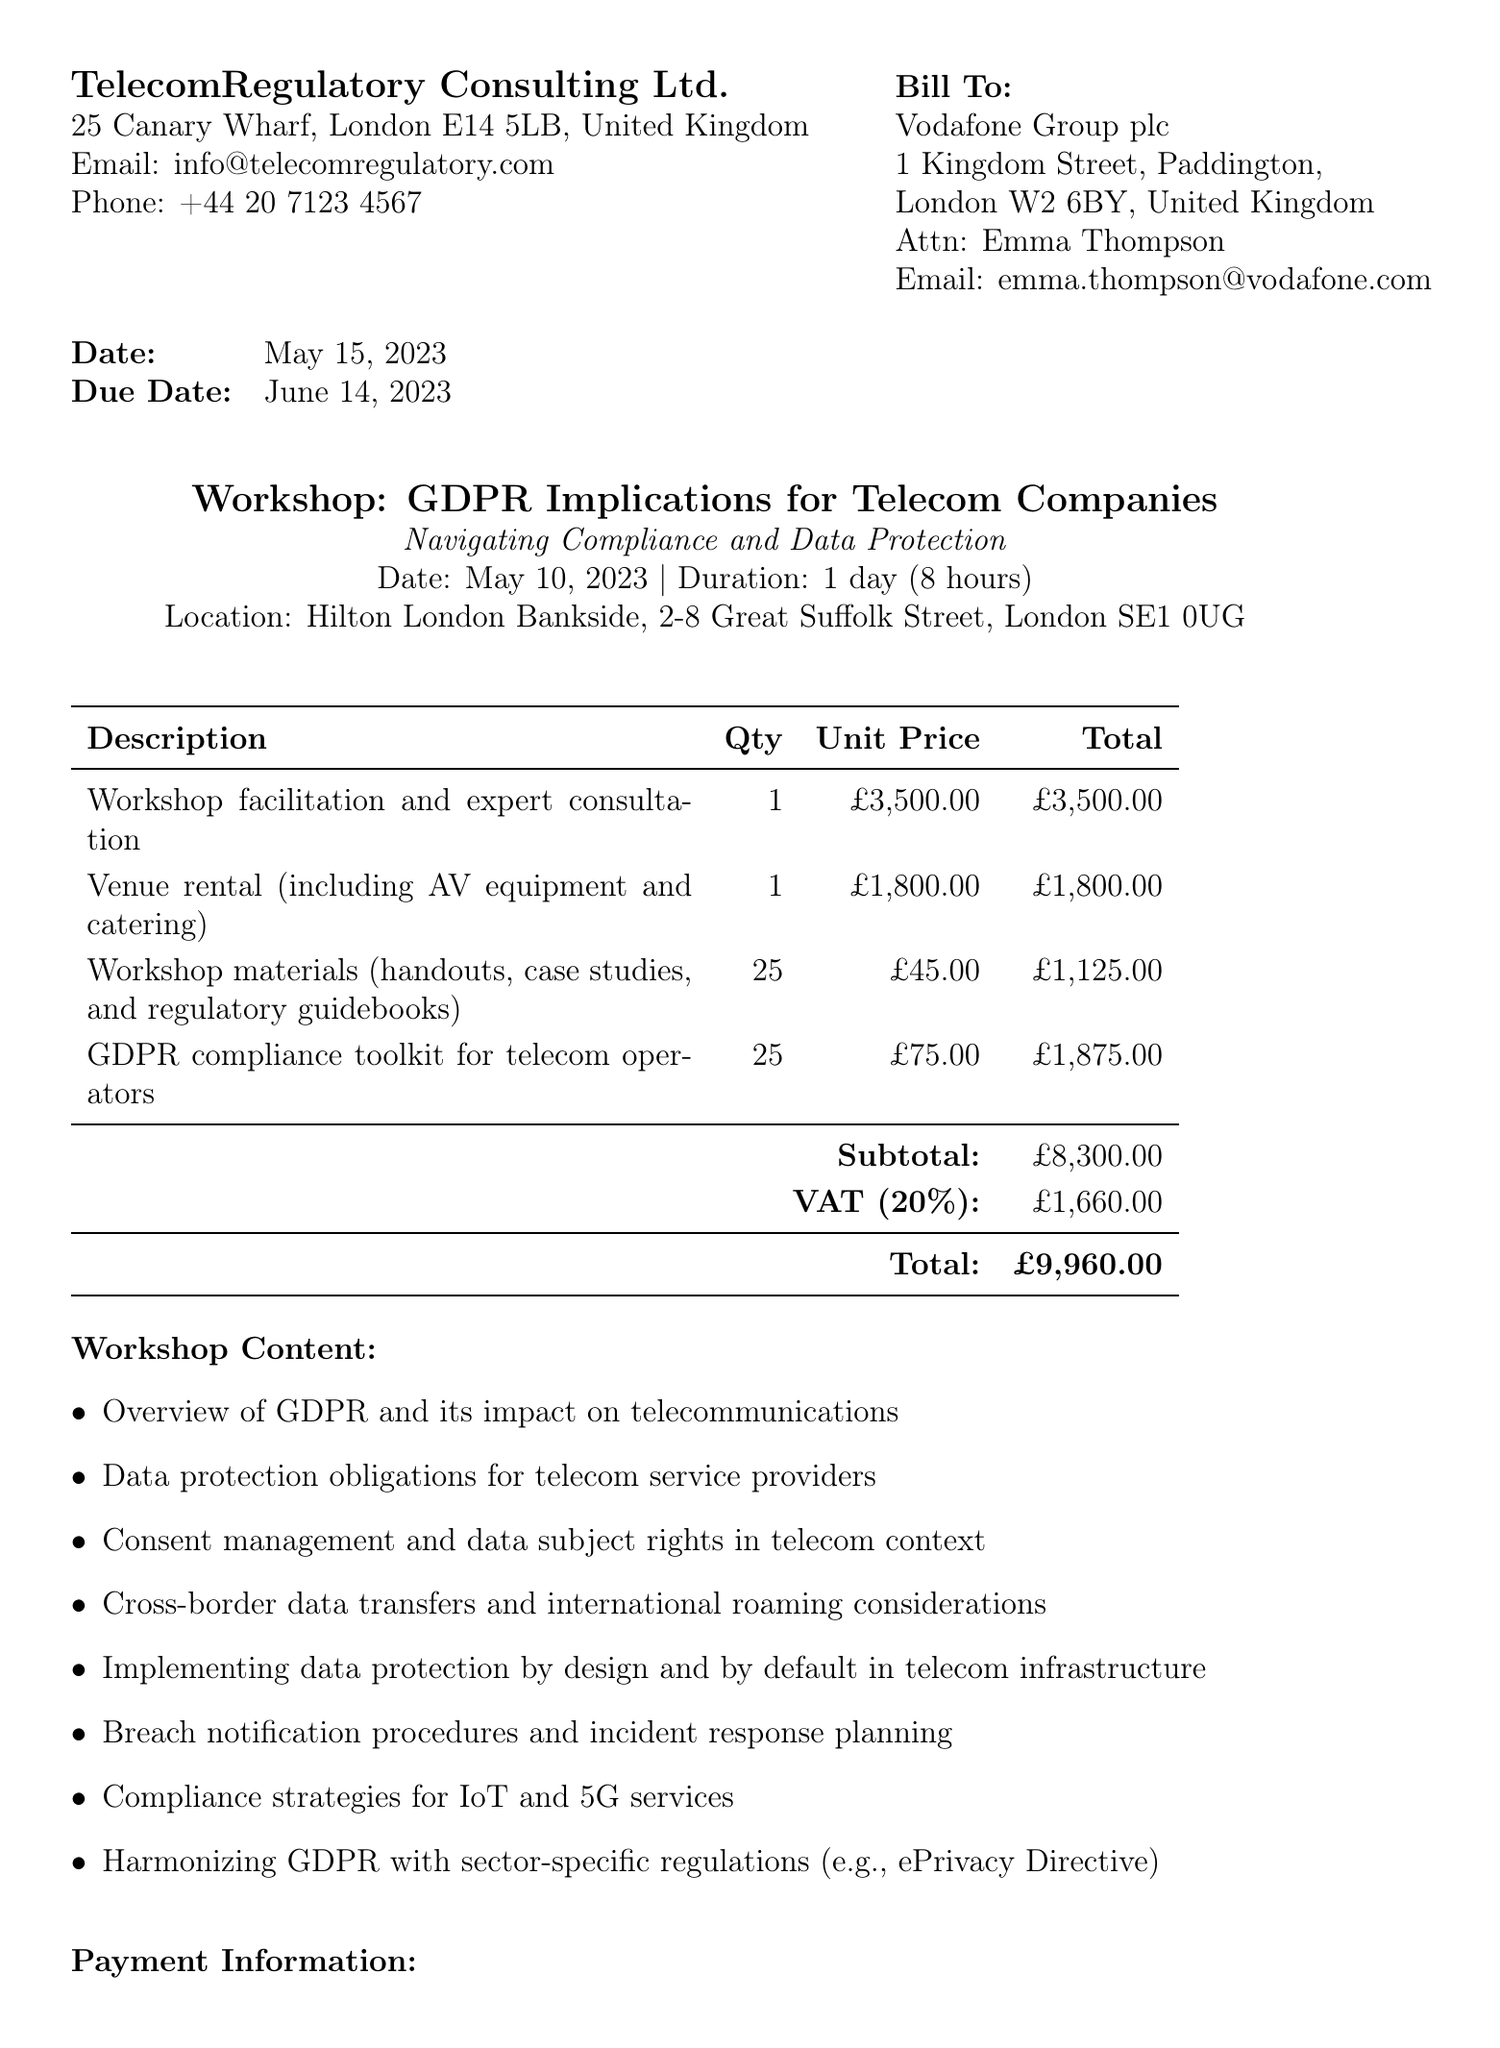what is the invoice number? The invoice number is clearly stated in the document for identification purposes.
Answer: INV-2023-0542 who is the contact person at Vodafone Group plc? The document provides contact information for the client, including the name of the contact person.
Answer: Emma Thompson what is the total amount due? The total amount is the final figure at the bottom of the invoice.
Answer: £9,960.00 when was the workshop held? The date of the workshop is listed under the workshop details section.
Answer: May 10, 2023 how many GDPR compliance toolkits were provided? The quantity of the compliance toolkits is specified in the line items section of the document.
Answer: 25 what is the payment terms for this invoice? Payment terms dictate the timeframe by which the payment should be made, indicated in the additional info section.
Answer: Net 30 what is the venue for the workshop? The location of the workshop is provided in the workshop details with the full address.
Answer: Hilton London Bankside, 2-8 Great Suffolk Street, London SE1 0UG what is included in the venue rental? The details under the line items describe what the venue rental covers.
Answer: AV equipment and catering 